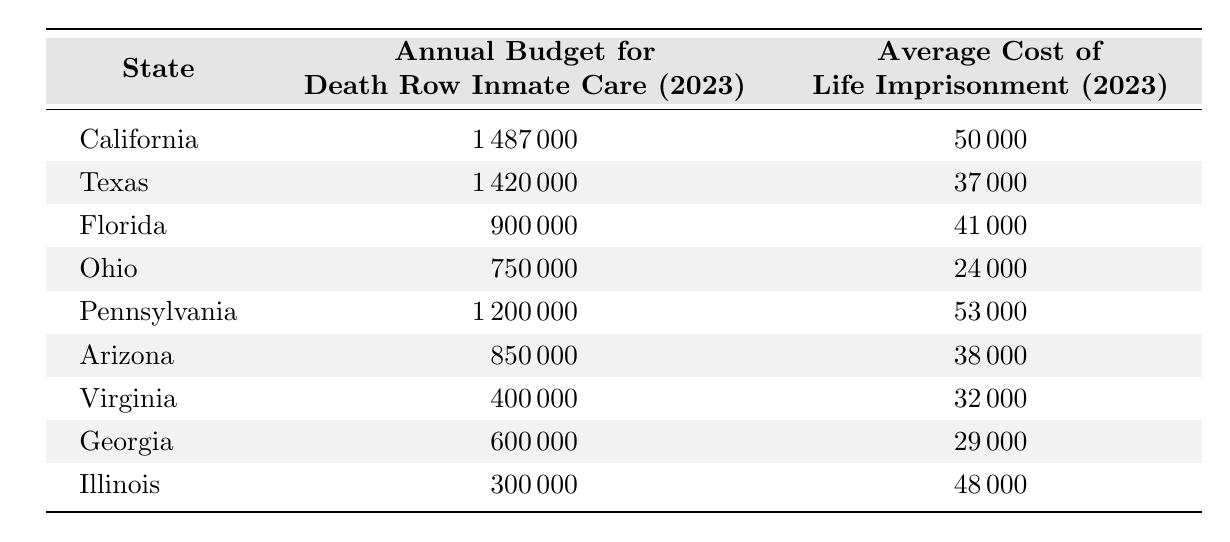What is the annual budget for death row inmate care in California? The table lists California with an annual budget for death row inmate care of 1,487,000.
Answer: 1,487,000 What is the average cost of life imprisonment in Texas? The table shows that the average cost of life imprisonment in Texas is 37,000.
Answer: 37,000 Which state has the lowest annual budget for death row inmate care? By comparing all the states listed, Illinois has the lowest annual budget for death row inmate care at 300,000.
Answer: Illinois Which state has the highest average cost of life imprisonment? The table indicates that Pennsylvania has the highest average cost of life imprisonment, which is 53,000.
Answer: Pennsylvania What is the difference between the annual budget for death row inmate care in Florida and the average cost of life imprisonment in Florida? The annual budget for death row inmate care in Florida is 900,000, and the average cost of life imprisonment is 41,000. The difference is 900,000 - 41,000 = 859,000.
Answer: 859,000 What is the average annual budget for death row inmate care across all states listed? To calculate the average, sum the budgets: 1,487,000 + 1,420,000 + 900,000 + 750,000 + 1,200,000 + 850,000 + 400,000 + 600,000 + 300,000 = 7,007,000. There are 9 states, so the average is 7,007,000 / 9 ≈ 778,556.
Answer: 778,556 Is the annual budget for death row inmate care in Georgia greater than the average cost of life imprisonment in Georgia? The budget for Georgia is 600,000, and the average cost of life imprisonment is 29,000. Since 600,000 is greater than 29,000, the answer is yes.
Answer: Yes Which state has a death row inmate care budget that exceeds the average cost of life imprisonment by more than 1 million? The budgets for California (1,487,000) and Texas (1,420,000) both exceed the average cost of life imprisonment in their states by more than 1 million.
Answer: California and Texas What is the total annual budget for death row inmate care for all the states combined? Adding the budgets together gives: 1,487,000 + 1,420,000 + 900,000 + 750,000 + 1,200,000 + 850,000 + 400,000 + 600,000 + 300,000 = 7,007,000.
Answer: 7,007,000 Does Ohio's annual budget for death row care equal or exceed the average cost of life imprisonment in Ohio? The budget for Ohio is 750,000 while the average cost of life imprisonment is 24,000. Since 750,000 is greater than 24,000, the answer is yes.
Answer: Yes 